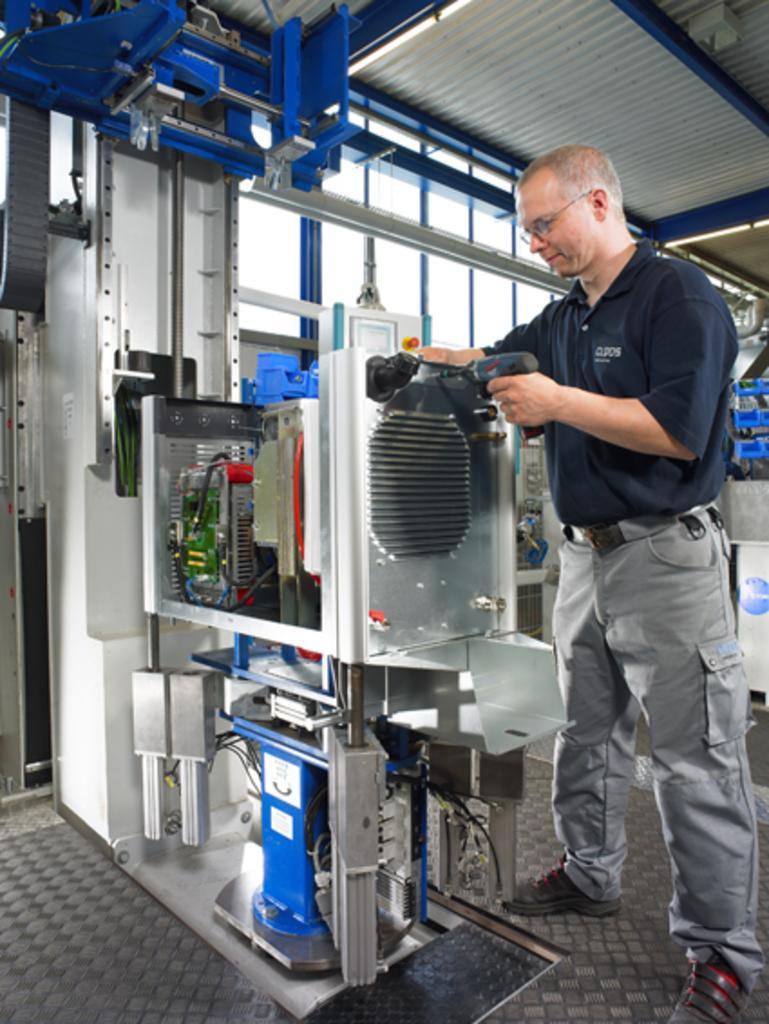In one or two sentences, can you explain what this image depicts? In this picture we can see a man wore a spectacle and standing on the floor and smiling and holding a machine with his hand and in the background we can see windows. 